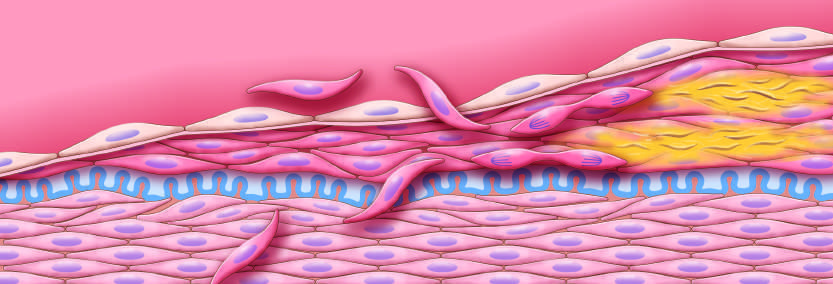s schematic diagram of intimal thickening emphasize intimal smooth muscle cell migration and proliferation associated with extracellular matrix synthesis?
Answer the question using a single word or phrase. Yes 